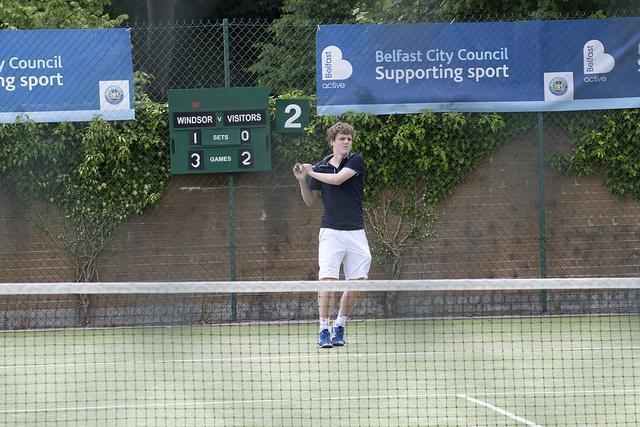How many oven racks are there?
Give a very brief answer. 0. 